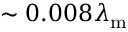<formula> <loc_0><loc_0><loc_500><loc_500>\sim 0 . 0 0 8 \lambda _ { m }</formula> 